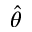<formula> <loc_0><loc_0><loc_500><loc_500>\hat { \theta }</formula> 